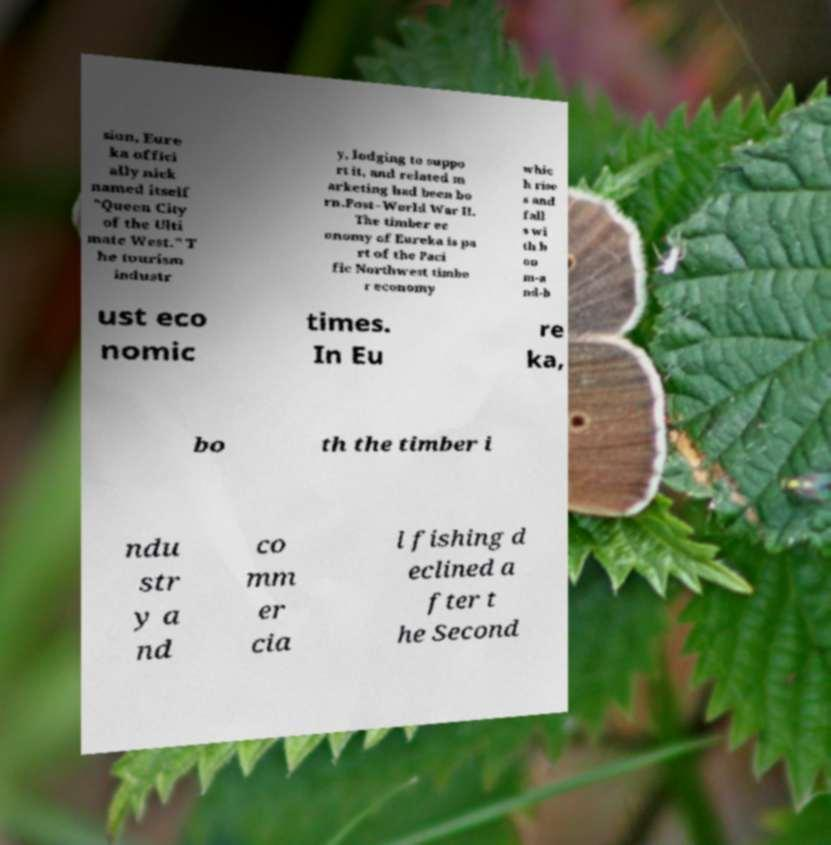What messages or text are displayed in this image? I need them in a readable, typed format. sion, Eure ka offici ally nick named itself "Queen City of the Ulti mate West." T he tourism industr y, lodging to suppo rt it, and related m arketing had been bo rn.Post–World War II. The timber ec onomy of Eureka is pa rt of the Paci fic Northwest timbe r economy whic h rise s and fall s wi th b oo m-a nd-b ust eco nomic times. In Eu re ka, bo th the timber i ndu str y a nd co mm er cia l fishing d eclined a fter t he Second 